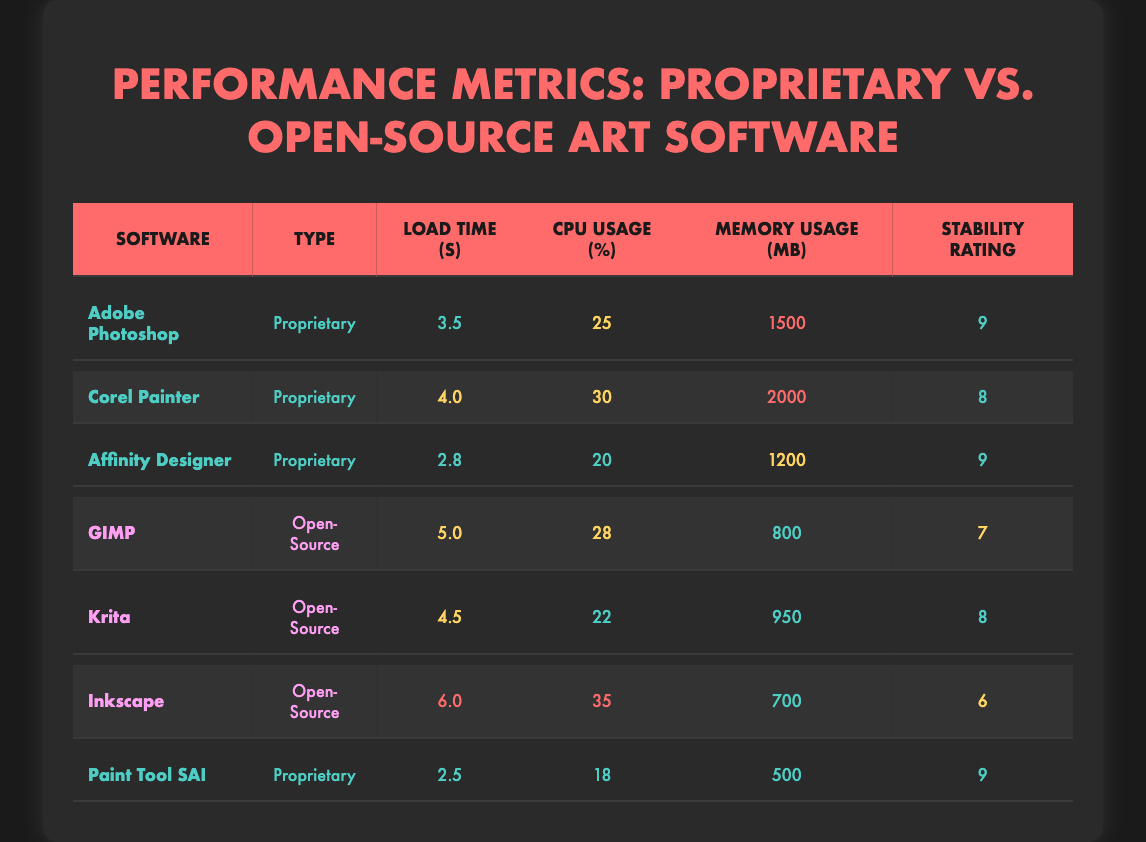What is the load time of Adobe Photoshop? Adobe Photoshop's load time is directly listed in the table under the "Load Time (seconds)" column. It shows a value of 3.5 seconds.
Answer: 3.5 seconds Which software has the highest stability rating? By comparing the "Stability Rating (1-10)" column for each software, Adobe Photoshop and Paint Tool SAI both have a rating of 9, which is the highest.
Answer: Adobe Photoshop and Paint Tool SAI What is the average CPU usage for open-source software? To find the average CPU usage for open-source software, we sum the CPU usage percentages of GIMP (28%), Krita (22%), and Inkscape (35%). The total is 85%, and with 3 software titles, the average is 85/3 = 28.33%.
Answer: 28.33% Is it true that all proprietary software have a load time under 5 seconds? By examining the "Load Time (seconds)" column, we see that Corel Painter (4.0 seconds) and Adobe Photoshop (3.5 seconds) have load times under 5 seconds, but both Affinity Designer (2.8 seconds) and Paint Tool SAI (2.5 seconds) also meet this criterion. However, Corel Painter loads in 4.0 seconds, which is under 5 seconds, making the statement true overall.
Answer: Yes Which software has the lowest memory usage, and what is its value? Looking through the "Memory Usage (MB)" column, Paint Tool SAI has the lowest value of 500 MB when compared with the other software listed.
Answer: Paint Tool SAI, 500 MB What is the difference in load time between the fastest and slowest proprietary software? The fastest proprietary software is Paint Tool SAI at 2.5 seconds, and the slowest is Corel Painter at 4.0 seconds. The difference is calculated as 4.0 - 2.5 = 1.5 seconds.
Answer: 1.5 seconds How many software titles have a stability rating of 8 or higher? Reviewing the "Stability Rating (1-10)" column, the following software have ratings of 8 or higher: Adobe Photoshop (9), Affinity Designer (9), Corel Painter (8), Krita (8), and Paint Tool SAI (9). This totals to five software titles.
Answer: 5 Which software consumes the most CPU usage and what is the percentage? In the "CPU Usage (%)" column, Inkscape has the highest percentage of 35%.
Answer: Inkscape, 35% Is Krita's load time greater than that of GIMP? Comparing the load times in the "Load Time (seconds)" column, Krita has a load time of 4.5 seconds and GIMP has 5.0 seconds. Since 4.5 seconds is less than 5.0 seconds, Krita's load time is not greater than GIMP's.
Answer: No 